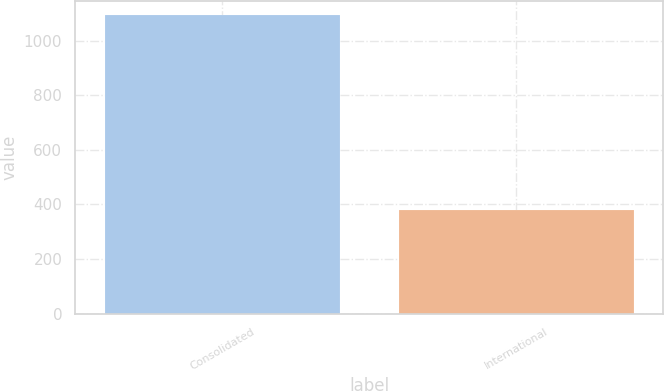<chart> <loc_0><loc_0><loc_500><loc_500><bar_chart><fcel>Consolidated<fcel>International<nl><fcel>1092<fcel>381.1<nl></chart> 